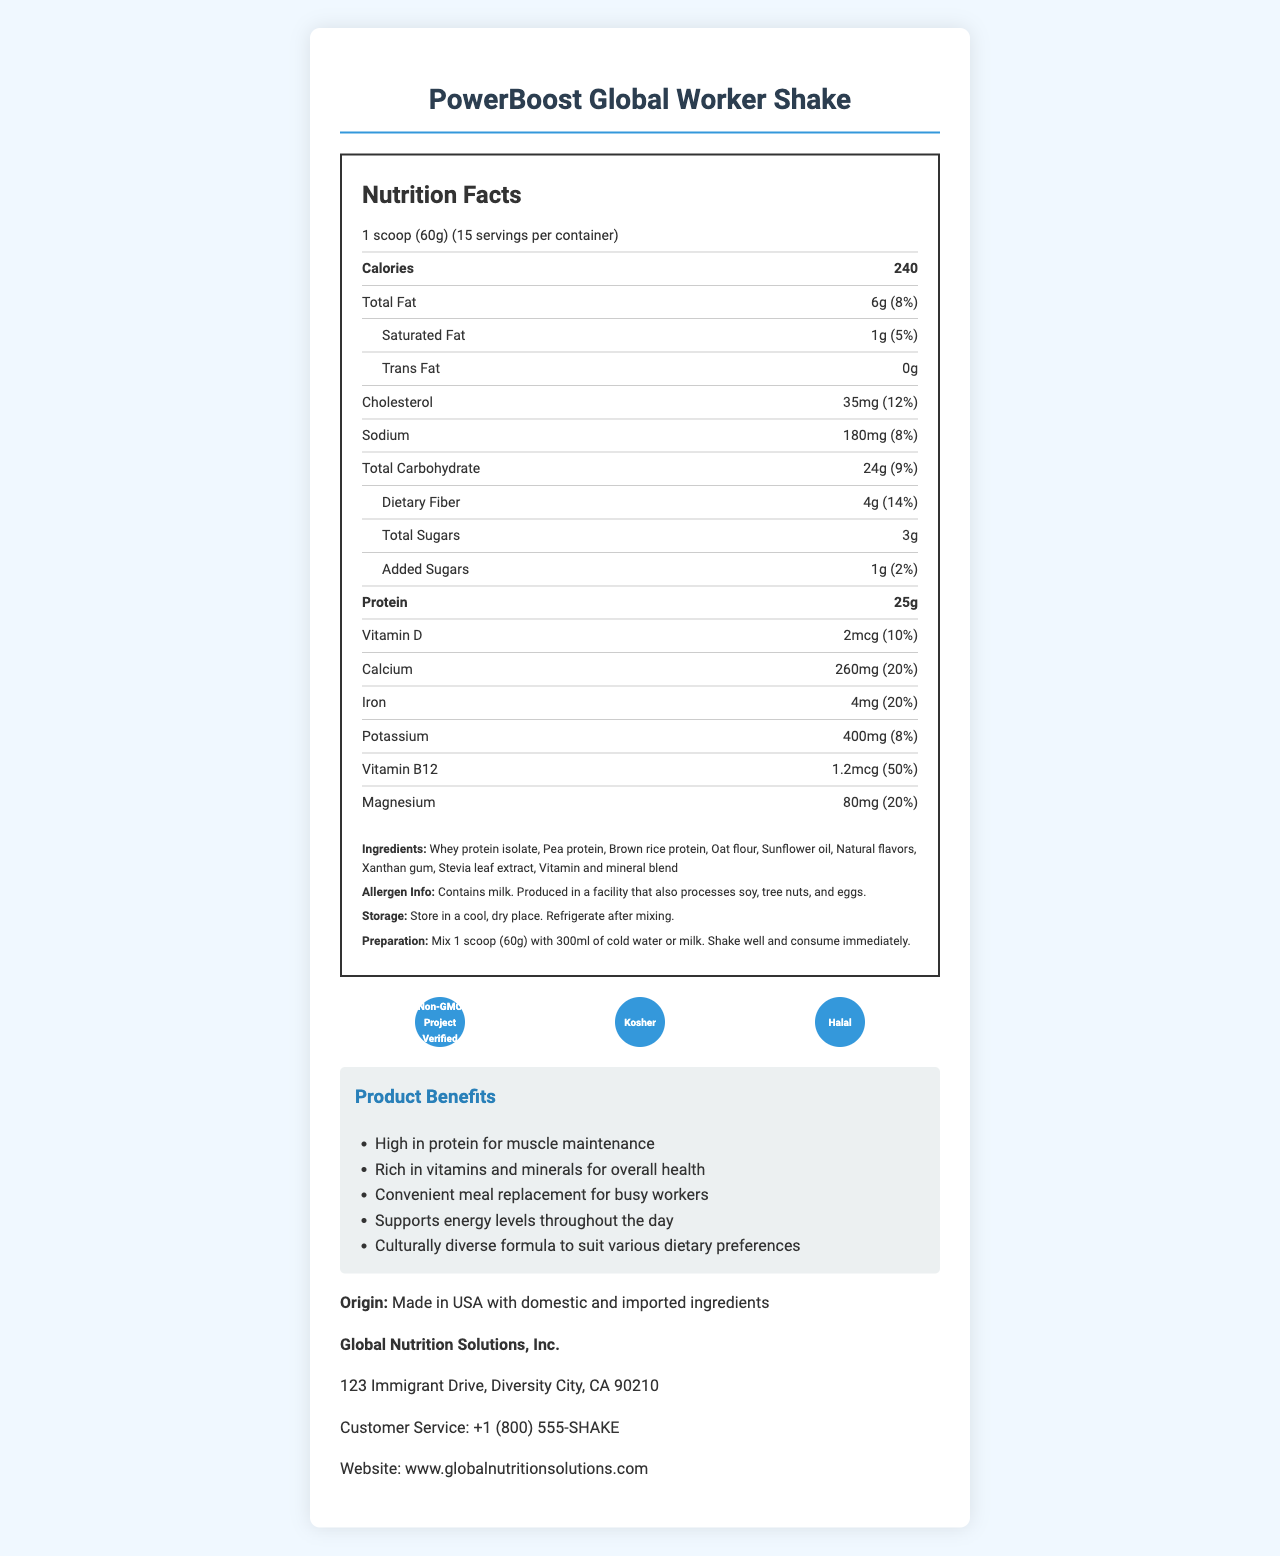which vitamin has the highest daily value percentage? The document lists Vitamin B12 as having a daily value of 50%, which is the highest among the vitamins presented.
Answer: Vitamin B12 what is the serving size of PowerBoost Global Worker Shake? The serving size is clearly indicated as 1 scoop, which equals 60 grams.
Answer: 1 scoop (60g) how many servings are in one container of the shake? The document states that there are 15 servings per container.
Answer: 15 how much protein is there per serving? The document indicates that each serving contains 25 grams of protein.
Answer: 25g what are the fat contents per serving? The nutritional facts show the total fat content as 6 grams, saturated fat as 1 gram, and trans fat as 0 grams per serving.
Answer: Total Fat: 6g, Saturated Fat: 1g, Trans Fat: 0g which of the following is not an ingredient in the shake? A. Whey protein isolate B. Pea protein C. Corn syrup D. Oat flour The ingredients list includes whey protein isolate, pea protein, and oat flour, but does not mention corn syrup.
Answer: C. Corn syrup what percentage of daily value does sodium contribute? The daily value percentage for sodium is 8%, as stated in the document.
Answer: 8% is the product suitable for vegans? The allergen information notes that the product contains milk, indicating it is not vegan.
Answer: No where is the product made? The document states that the product is made in the USA with domestic and imported ingredients.
Answer: USA with domestic and imported ingredients what should be done after mixing the shake? A. Store it at room temperature B. Consume immediately C. Refrigerate and consume later D. Freeze for better taste The preparation instructions specify that the shake should be consumed immediately after mixing.
Answer: B. Consume immediately is there any added sugar in the shake? The document mentions that there is 1 gram of added sugars, contributing to 2% of the daily value.
Answer: Yes how should the shake be stored before mixing? The storage instructions recommend storing the product in a cool, dry place before mixing.
Answer: In a cool, dry place does the document specify the amount of Vitamin C in the shake? The document does not provide information about Vitamin C content.
Answer: I don't know Provide a summary of the document. The summary encapsulates the key points of the nutrition label and additional information provided in the document.
Answer: The document provides nutritional information for the PowerBoost Global Worker Shake, a protein-rich meal replacement designed for busy immigrant workers. It includes specific details about serving size, number of servings per container, calorie count, and various nutrient amounts and daily values. The document also lists ingredients, storage and preparation instructions, allergen information, the product's origin, and the company's contact details. Additionally, it highlights the product's certifications and benefits for the target audience. 